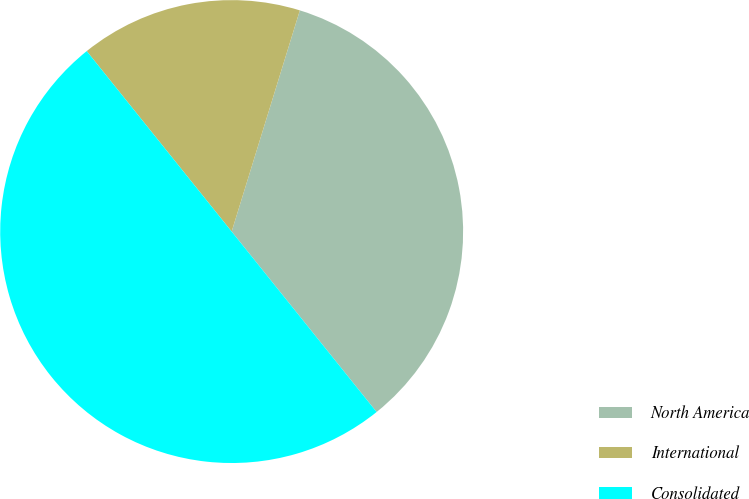Convert chart to OTSL. <chart><loc_0><loc_0><loc_500><loc_500><pie_chart><fcel>North America<fcel>International<fcel>Consolidated<nl><fcel>34.47%<fcel>15.53%<fcel>50.0%<nl></chart> 